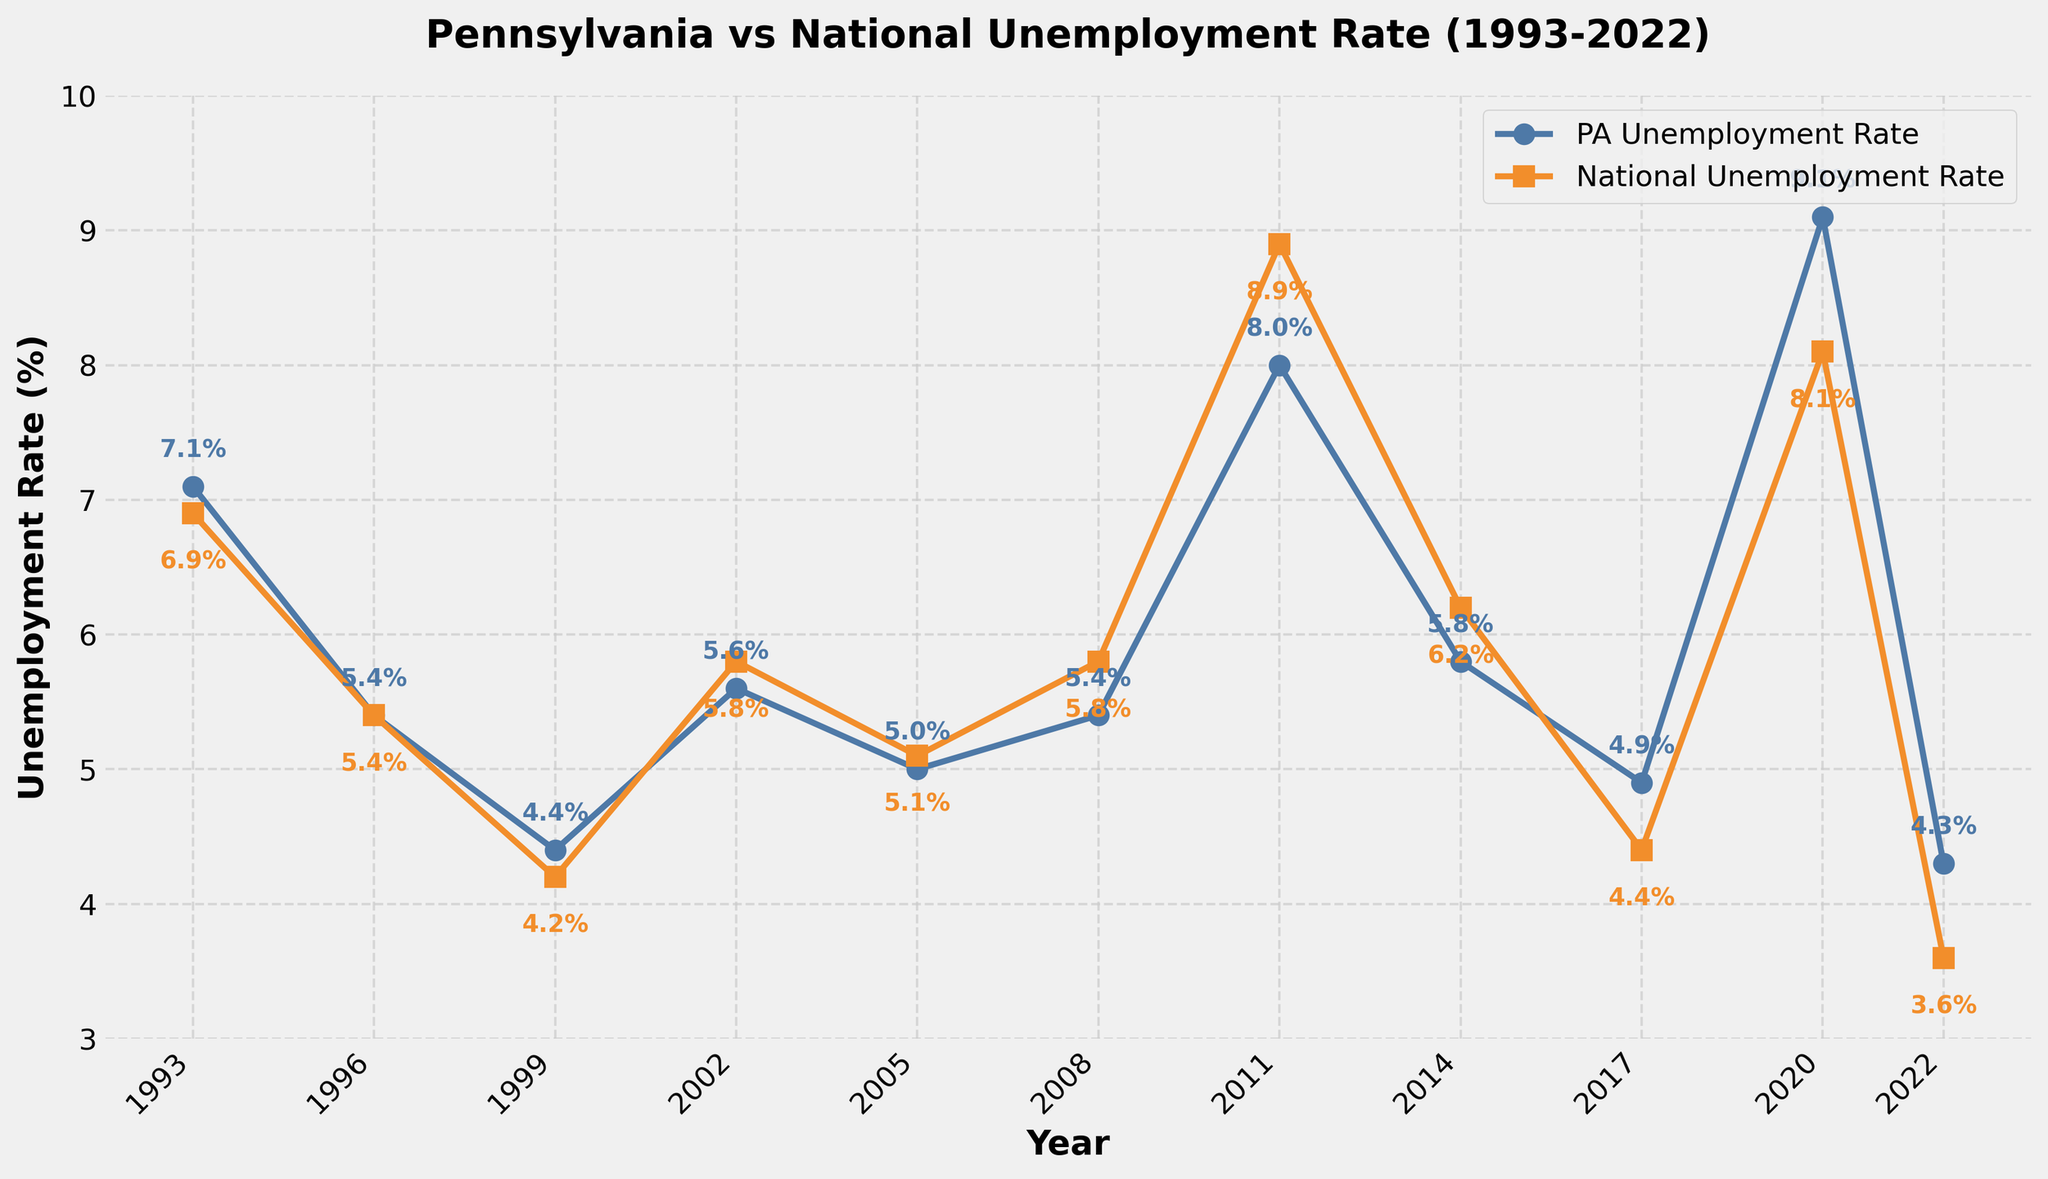what is the highest unemployment rate for Pennsylvania (PA) in the data? Look at the line for Pennsylvania and identify the highest point on the chart, which corresponds to the highest unemployment rate.
Answer: 9.1% How did the national unemployment rate compare to Pennsylvania's in 2011? Find the points for 2011 on both lines. Compare the two values to see which is higher or if they are equal.
Answer: The national rate was higher What years did Pennsylvania's unemployment rate equal the national rate? Identify the years where the two lines intersect, indicating equal unemployment rates.
Answer: 1996, 2002 What's the average unemployment rate in PA over the last 10 years? Take the PA unemployment rates for the last 10 years: (2013-2022: 8.0, 5.8, 4.9, 9.1, 4.3). Sum these values and divide by the number of years.
Answer: 6.42% In which year did Pennsylvania have the biggest gap between its unemployment rate and the national rate? Calculate the absolute differences between PA and National rates for each year. Identify the year with the largest gap.
Answer: 2022 When did Pennsylvania last report an unemployment rate below 5%? Follow the line for Pennsylvania and identify the last point where the rate drops below 5%.
Answer: 2022 What can you say about the trend of both Pennsylvania and national unemployment rates from 2011 to 2022? Evaluate the overall direction of both lines between 2011 and 2022 to understand their trends.
Answer: Both rates dropped overall Compare the unemployment trends for PA and the national average from 2008 to 2011. Examine the slopes of the lines between the years 2008 and 2011 for both PA and the national average.
Answer: Both increased, with the national rate rising faster How often did Pennsylvania's unemployment rate fall below the national average in the given period? Count the instances where the PA line is below the national line.
Answer: 4 times 